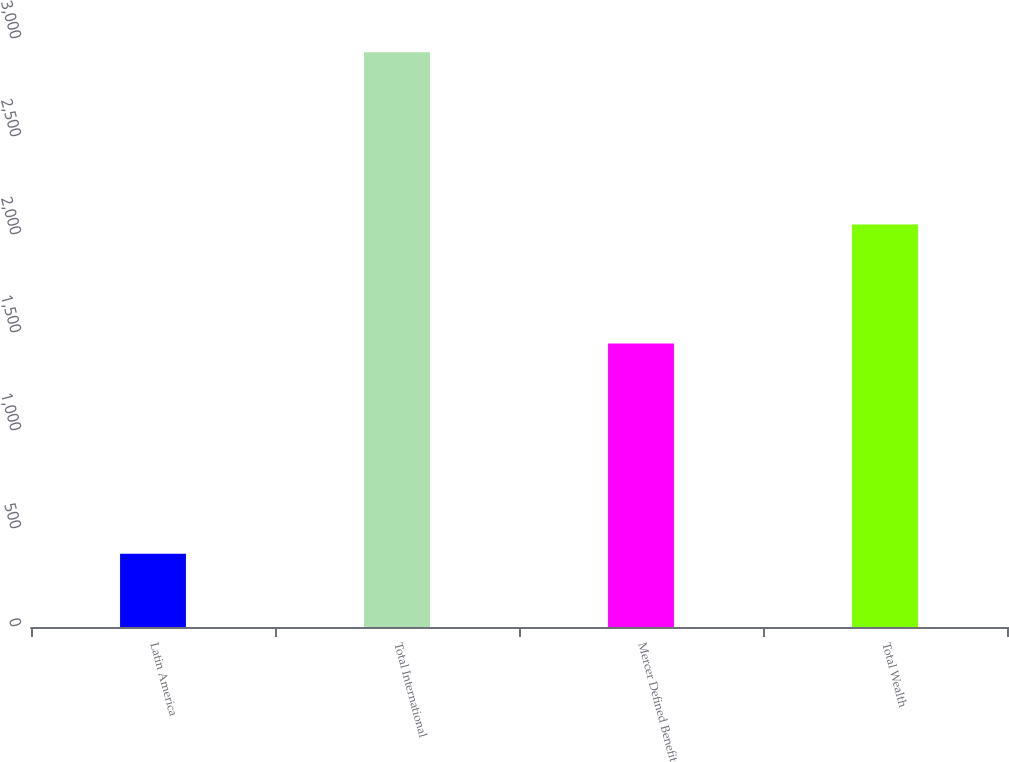Convert chart to OTSL. <chart><loc_0><loc_0><loc_500><loc_500><bar_chart><fcel>Latin America<fcel>Total International<fcel>Mercer Defined Benefit<fcel>Total Wealth<nl><fcel>374<fcel>2933<fcel>1447<fcel>2053<nl></chart> 